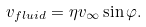<formula> <loc_0><loc_0><loc_500><loc_500>v _ { f l u i d } = \eta v _ { \infty } \sin \varphi .</formula> 